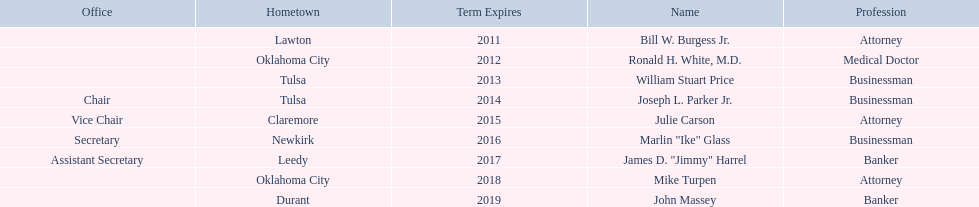Which regents are from tulsa? William Stuart Price, Joseph L. Parker Jr. Which of these is not joseph parker, jr.? William Stuart Price. 